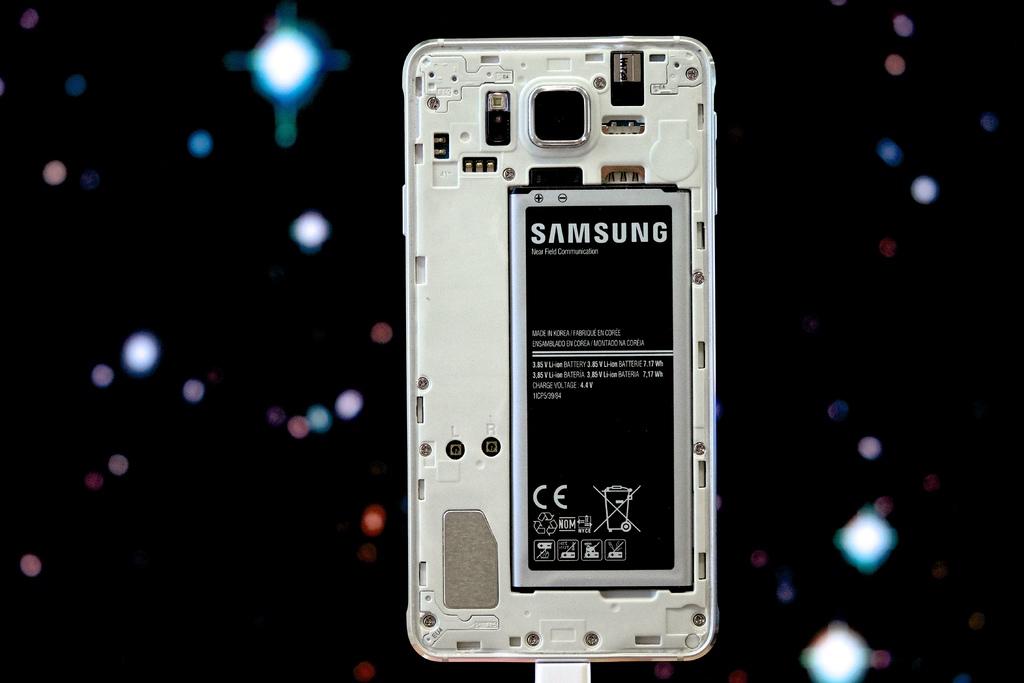What brand is the battery?
Offer a very short reply. Samsung. Is this a samsung battery?
Provide a short and direct response. Yes. 